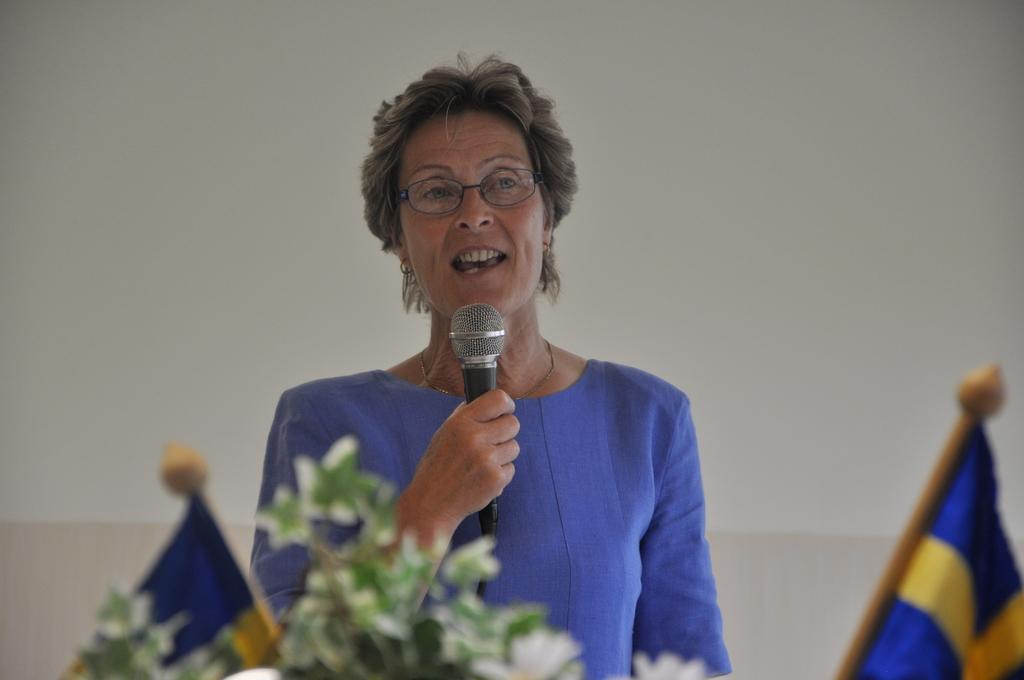Who is the main subject in the image? There is a woman in the image. What is the woman doing in the image? The woman is standing and speaking with the help of a microphone. What can be seen on the podium in the image? There are two flags on a podium in the image. What type of crib is visible in the image? There is no crib present in the image. What agreement was reached between the two parties in the image? The image does not depict any agreement being reached between two parties. 